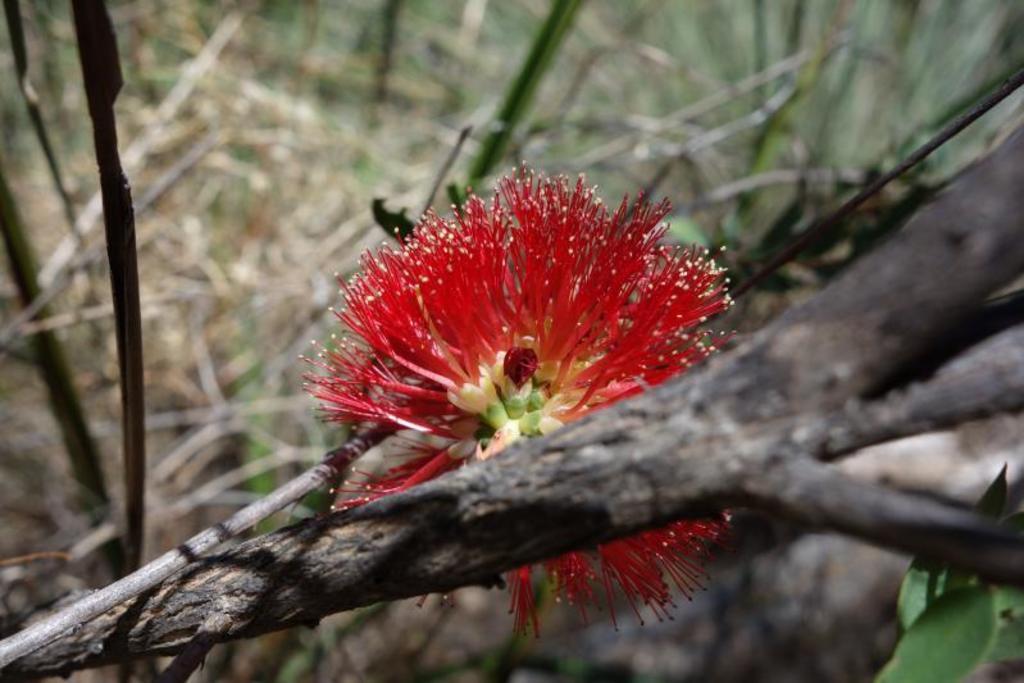Could you give a brief overview of what you see in this image? It is a beautiful red color flower in the middle of an image. There are trees in this image. 